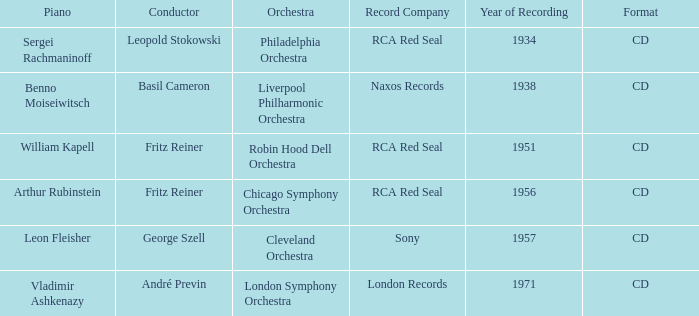Where is the orchestra when the year of recording is 1934? Philadelphia Orchestra. 